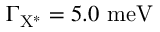Convert formula to latex. <formula><loc_0><loc_0><loc_500><loc_500>\Gamma _ { { X ^ { * } } } = 5 . 0 { m e V }</formula> 